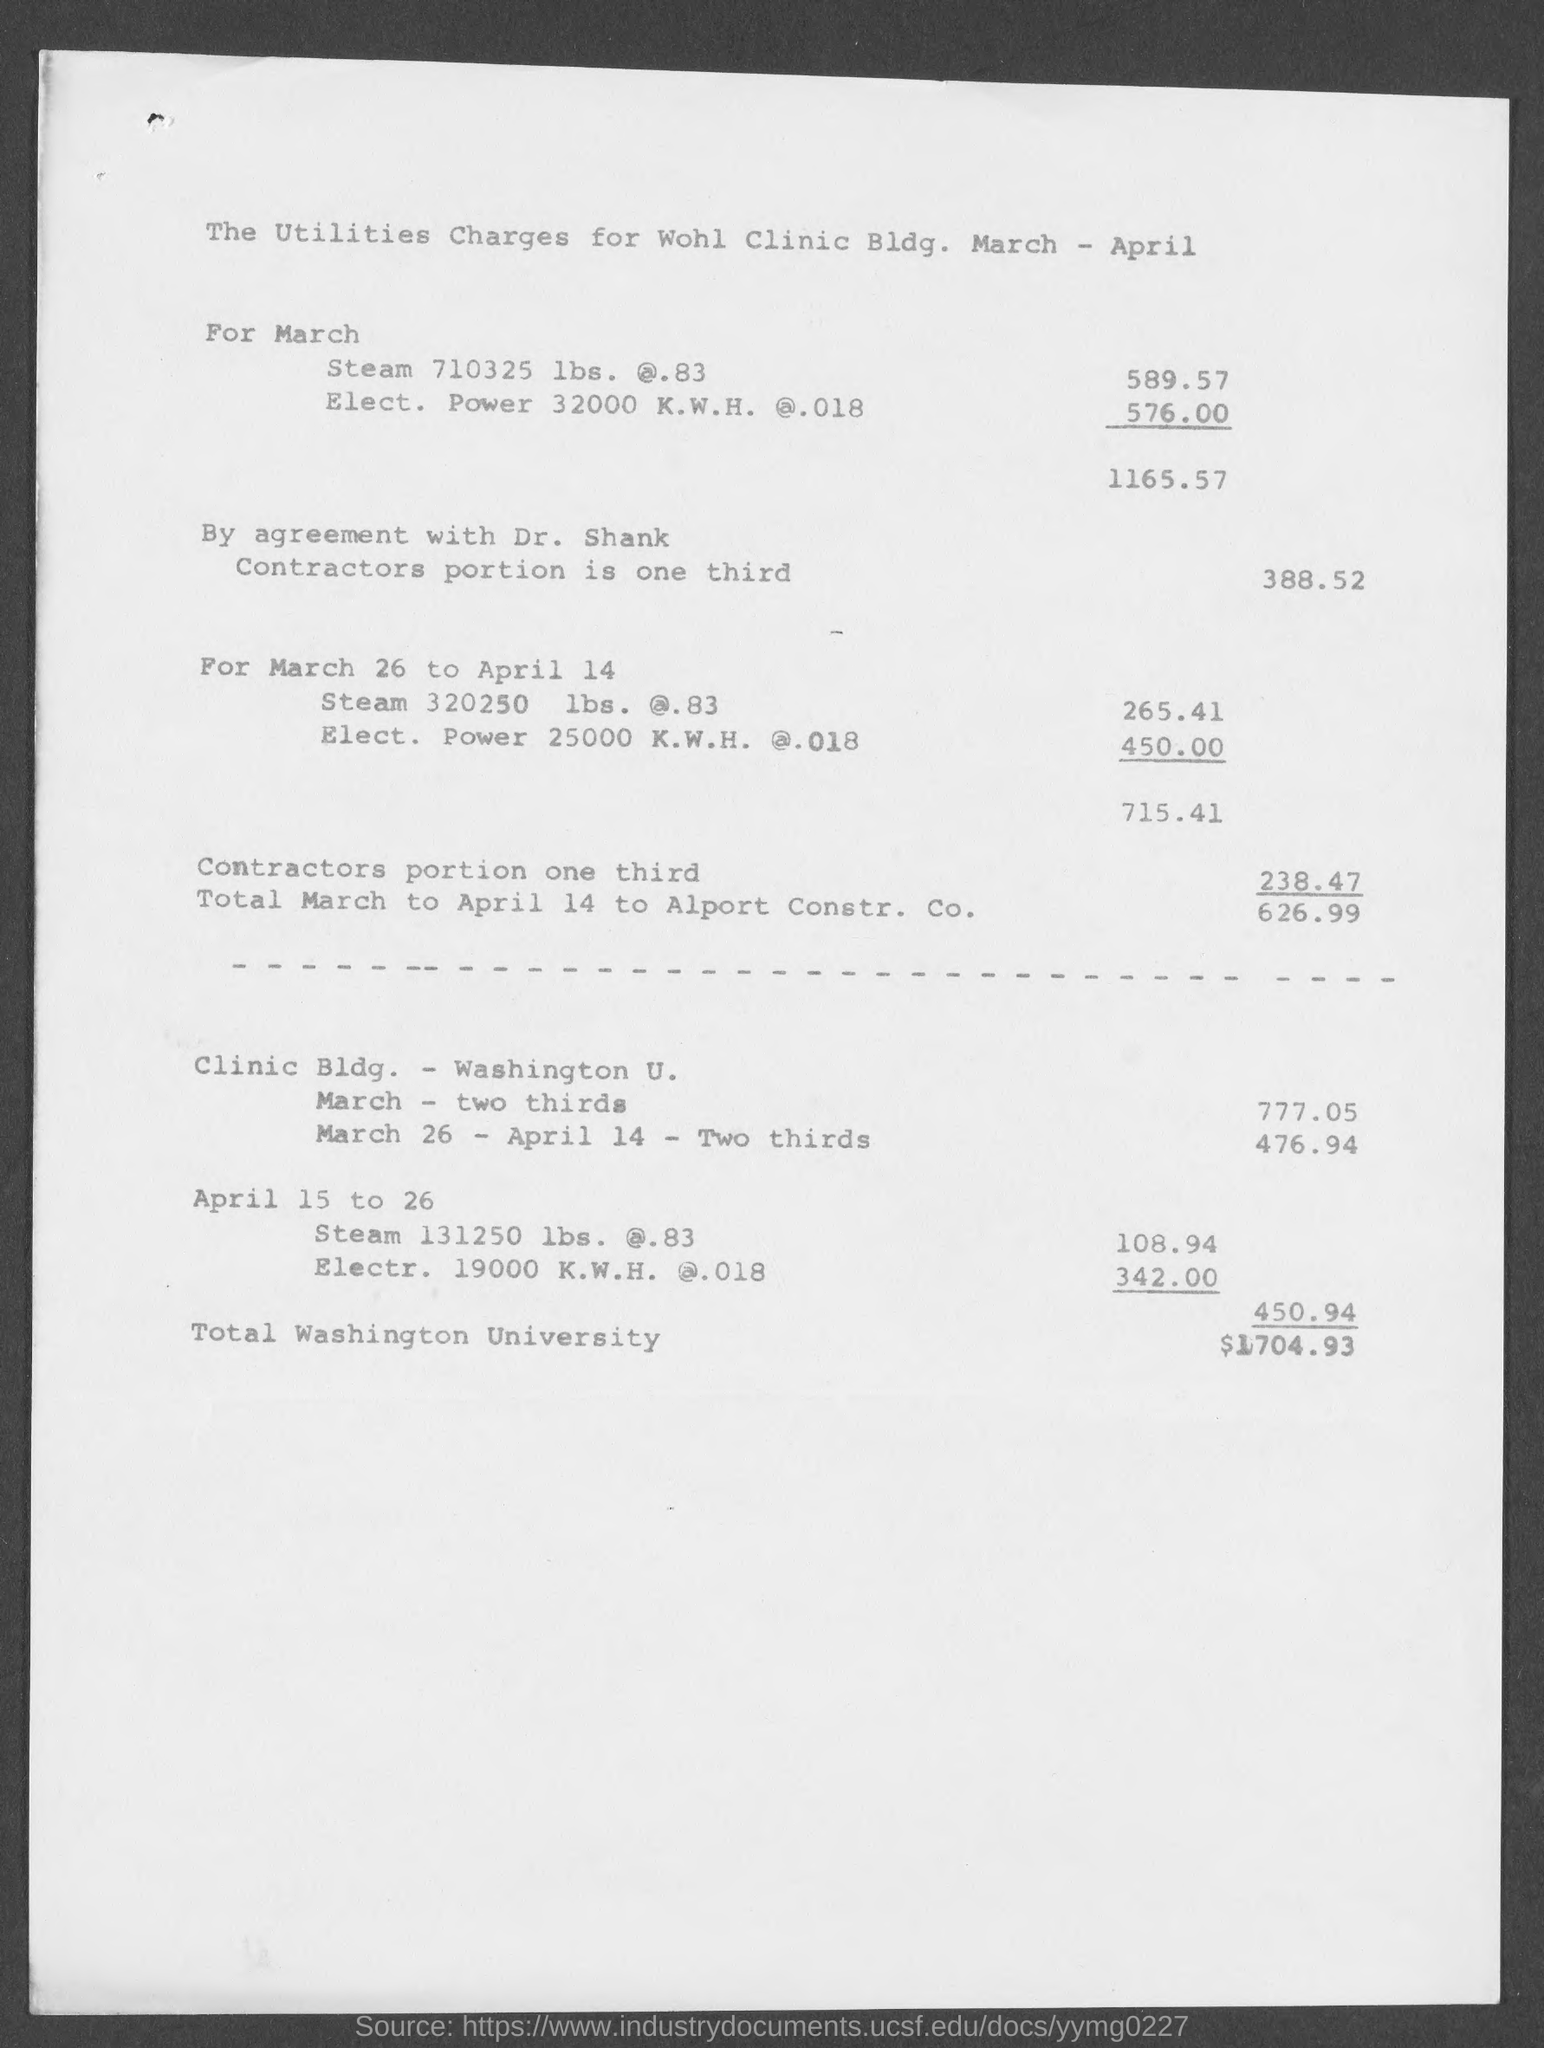Draw attention to some important aspects in this diagram. The cost of Steam 320250 pounds, valued at $0.83, for the period of March 26 to April 14 is approximately $265.41. The cost of 25,000 Kilowatt-hours of electric power at a rate of 0.018 per Kilowatt-hour for the period of March 26 to April 14 is 450.00. The cost of 19,000 kilowatt-hours of electricity at a rate of 0.018 per kilowatt-hour from April 15 to April 26 is approximately $342.00. The total cost from March 26 to April 14 is 715.41 dollars. Utilities charges for March and April are shown. 